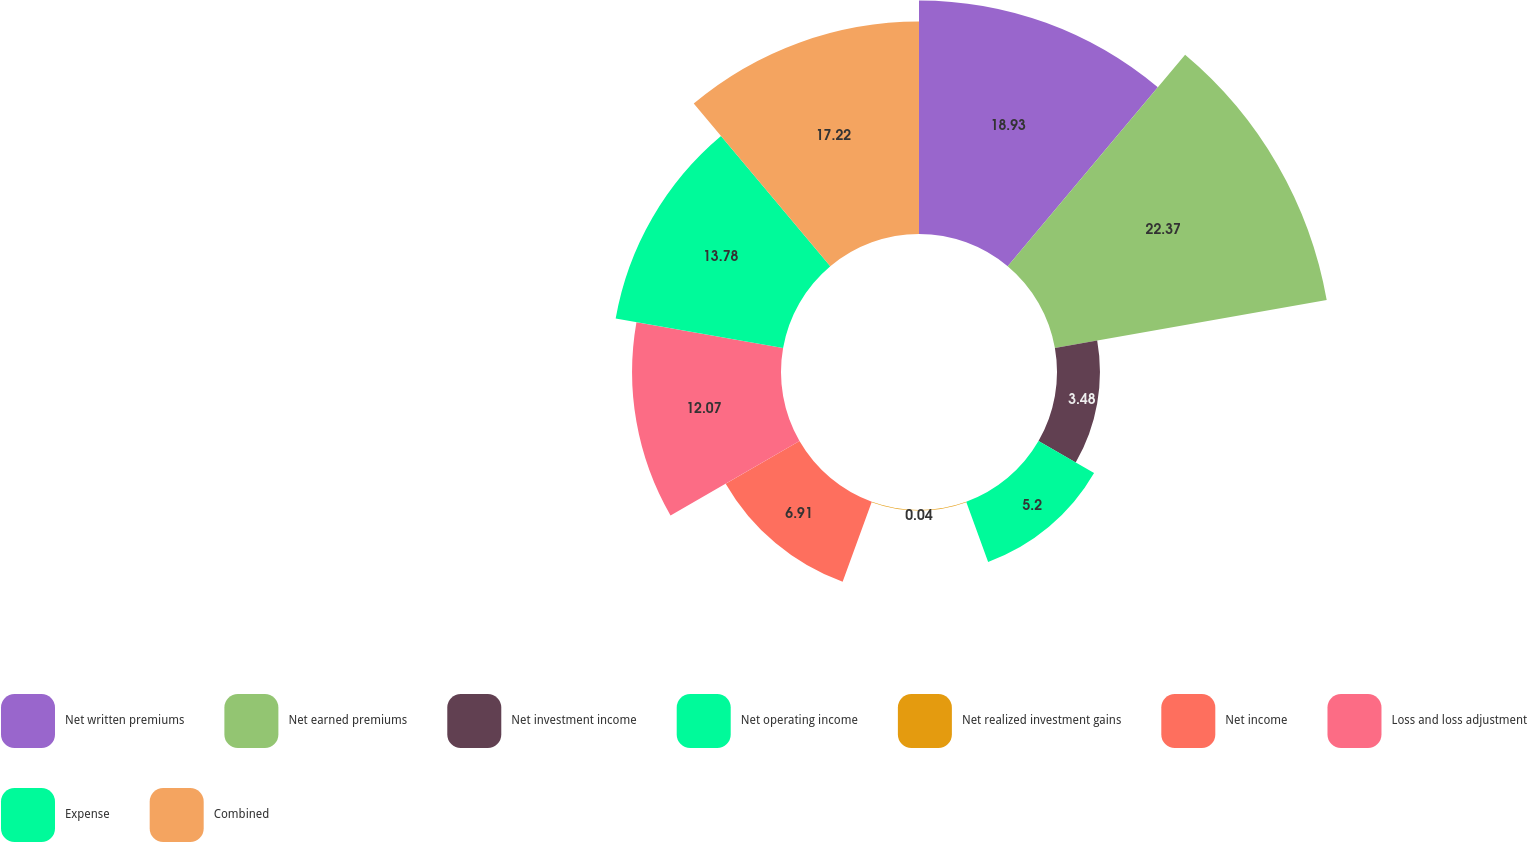Convert chart to OTSL. <chart><loc_0><loc_0><loc_500><loc_500><pie_chart><fcel>Net written premiums<fcel>Net earned premiums<fcel>Net investment income<fcel>Net operating income<fcel>Net realized investment gains<fcel>Net income<fcel>Loss and loss adjustment<fcel>Expense<fcel>Combined<nl><fcel>18.93%<fcel>22.37%<fcel>3.48%<fcel>5.2%<fcel>0.04%<fcel>6.91%<fcel>12.07%<fcel>13.78%<fcel>17.22%<nl></chart> 